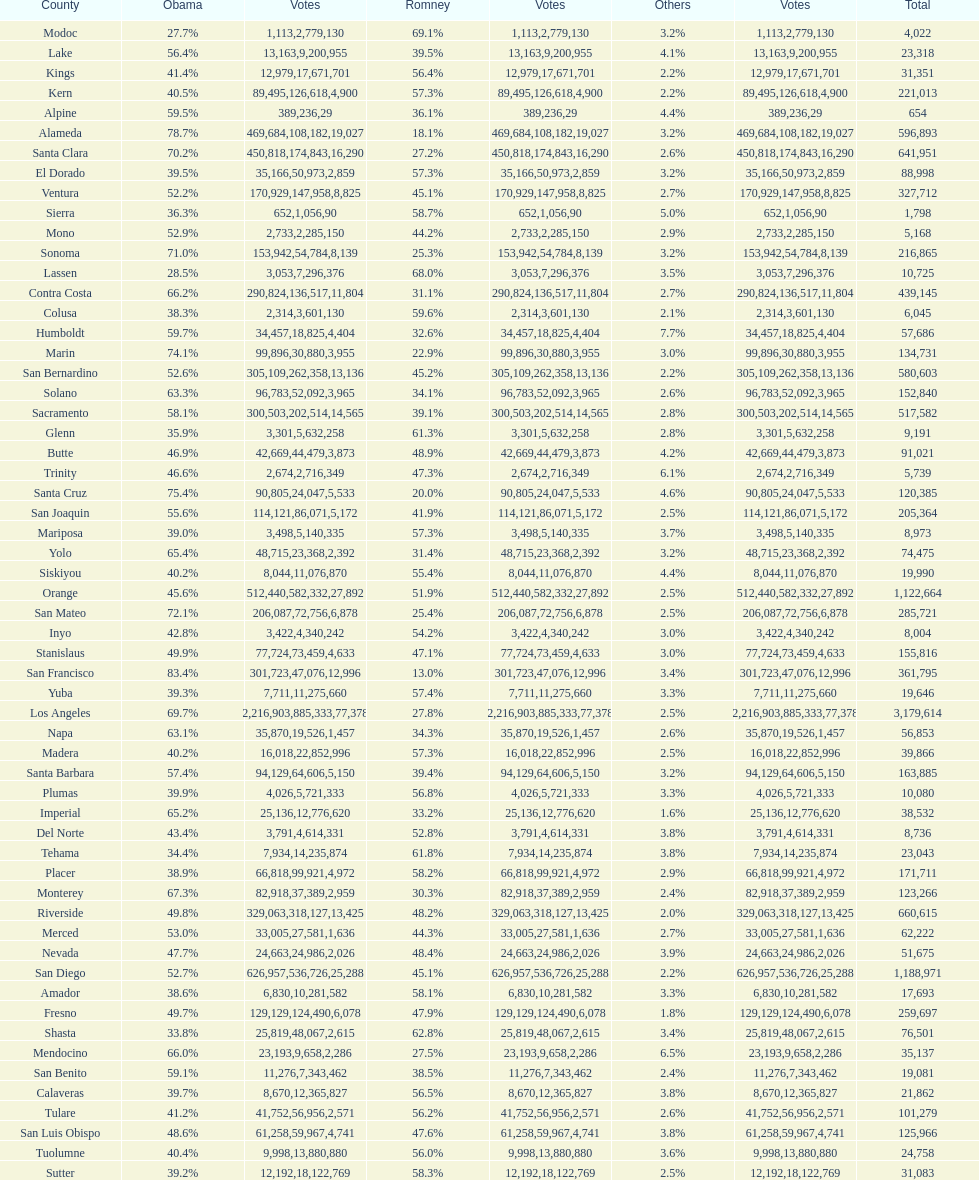What is the total number of votes for amador? 17693. 